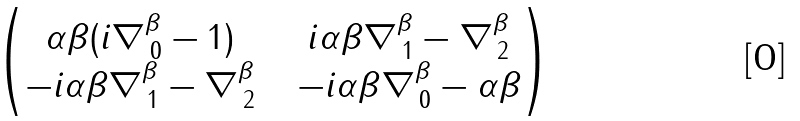<formula> <loc_0><loc_0><loc_500><loc_500>\begin{pmatrix} \alpha \beta ( i \nabla ^ { \beta } _ { \, 0 } - 1 ) \ \ & i \alpha \beta \nabla ^ { \beta } _ { \, 1 } - \nabla ^ { \beta } _ { \, 2 } \\ - i \alpha \beta \nabla ^ { \beta } _ { \, 1 } - \nabla ^ { \beta } _ { \, 2 } \ \ & - i \alpha \beta \nabla ^ { \beta } _ { \, 0 } - \alpha \beta \end{pmatrix}</formula> 